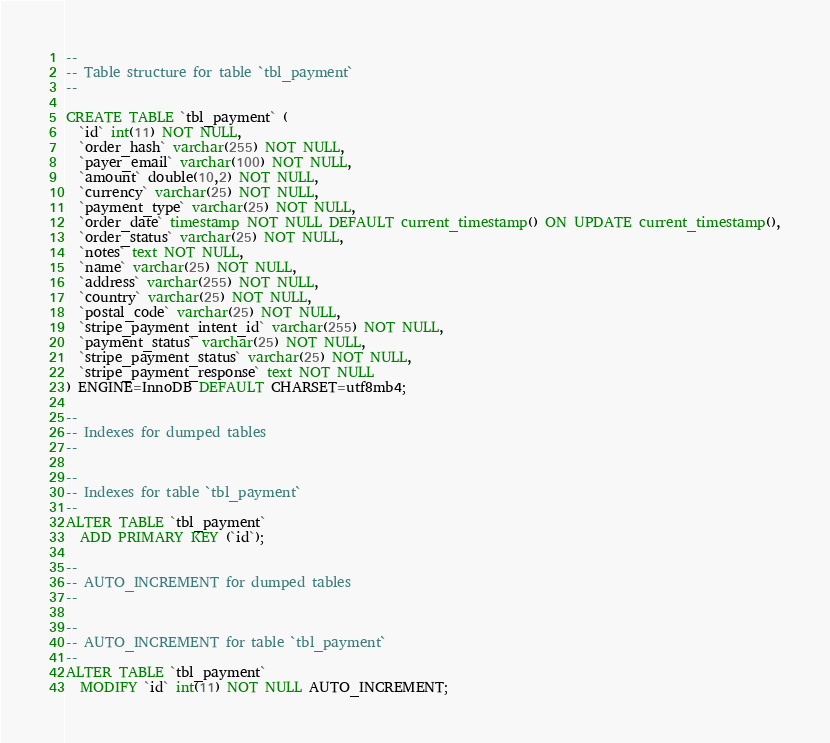Convert code to text. <code><loc_0><loc_0><loc_500><loc_500><_SQL_>--
-- Table structure for table `tbl_payment`
--

CREATE TABLE `tbl_payment` (
  `id` int(11) NOT NULL,
  `order_hash` varchar(255) NOT NULL,
  `payer_email` varchar(100) NOT NULL,
  `amount` double(10,2) NOT NULL,
  `currency` varchar(25) NOT NULL,
  `payment_type` varchar(25) NOT NULL,
  `order_date` timestamp NOT NULL DEFAULT current_timestamp() ON UPDATE current_timestamp(),
  `order_status` varchar(25) NOT NULL,
  `notes` text NOT NULL,
  `name` varchar(25) NOT NULL,
  `address` varchar(255) NOT NULL,
  `country` varchar(25) NOT NULL,
  `postal_code` varchar(25) NOT NULL,
  `stripe_payment_intent_id` varchar(255) NOT NULL,
  `payment_status` varchar(25) NOT NULL,
  `stripe_payment_status` varchar(25) NOT NULL,
  `stripe_payment_response` text NOT NULL
) ENGINE=InnoDB DEFAULT CHARSET=utf8mb4;

--
-- Indexes for dumped tables
--

--
-- Indexes for table `tbl_payment`
--
ALTER TABLE `tbl_payment`
  ADD PRIMARY KEY (`id`);

--
-- AUTO_INCREMENT for dumped tables
--

--
-- AUTO_INCREMENT for table `tbl_payment`
--
ALTER TABLE `tbl_payment`
  MODIFY `id` int(11) NOT NULL AUTO_INCREMENT;
</code> 